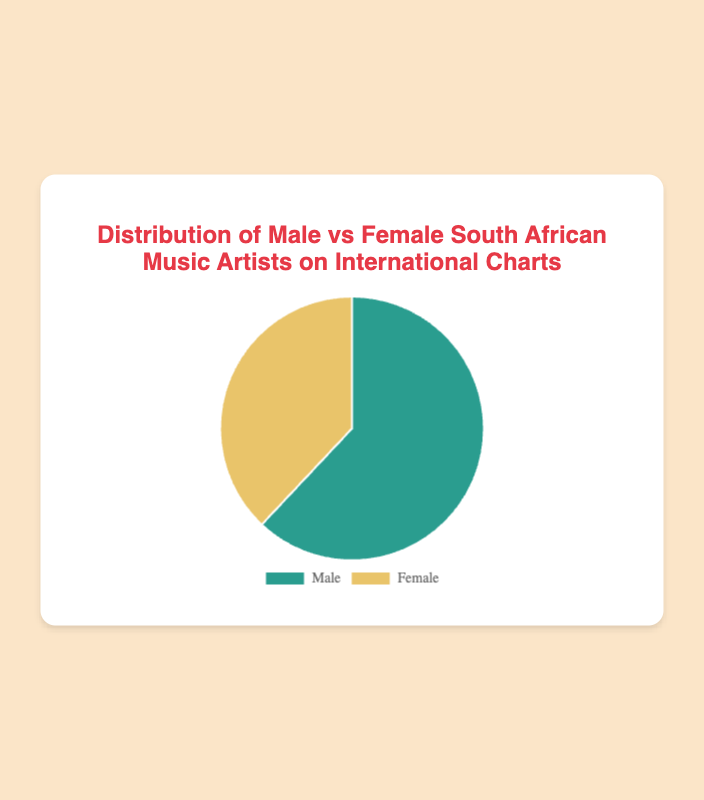How many more South African male music artists are on international charts compared to female artists? There are 62% male artists and 38% female artists. The difference is 62 - 38.
Answer: 24% Which gender has a higher representation on the international charts? The chart shows that males have a 62% representation, and females have a 38% representation. Since 62% is greater than 38%, males have a higher representation.
Answer: Males What is the combined percentage of both male and female South African music artists on international charts? The total percentage for both male and female artists should add up to 100% (since they are the only two categories in the pie chart). Therefore, adding 62% and 38% gives 100%.
Answer: 100% If you were to convert the male representation into a fraction, what would it be? Male representation is 62%. To convert this into a fraction, divide by 100: 62/100, which simplifies to 31/50.
Answer: 31/50 What is the ratio of male to female South African music artists on international charts? The percentage of male artists is 62% and female artists is 38%. To find the ratio, divide the two: 62/38, which simplifies to approximately 1.63.
Answer: 1.63:1 If the chart's colors are described, which color represents the male artists? The chart uses different colors for each category. According to the data section, the 'Male' category is shown in green.
Answer: Green What percentage of South African music artists on international charts are not male? The chart shows 62% male and the remaining 38% are female. Therefore, 100% minus the percentage of male artists gives the percentage of non-male artists, 100 - 62.
Answer: 38% What would be the average percentage representation if male and female South African music artists had equal representation? If males and females were equally represented, each would be 100% / 2 = 50%.
Answer: 50% By what factor do male South African music artists outnumber female artists on international charts? Male artists represent 62%, and female artists represent 38%. The factor by which males outnumber females is 62 / 38, simplifying to approximately 1.63.
Answer: 1.63 Determine the female representation as a fraction of the total artists using the lowest terms. Female representation is 38%. As a fraction, this is 38/100, which simplifies to 19/50.
Answer: 19/50 